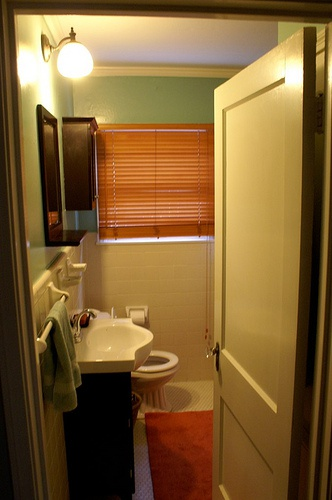Describe the objects in this image and their specific colors. I can see sink in black, tan, olive, and maroon tones and toilet in black, maroon, and olive tones in this image. 